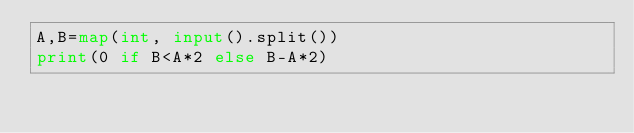<code> <loc_0><loc_0><loc_500><loc_500><_Python_>A,B=map(int, input().split())
print(0 if B<A*2 else B-A*2)</code> 